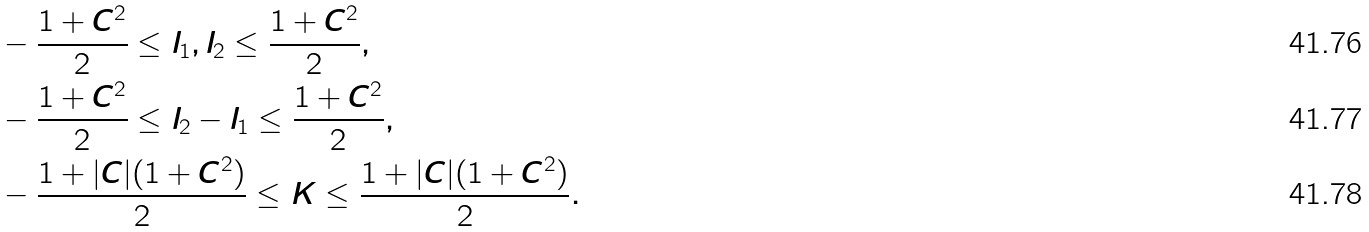Convert formula to latex. <formula><loc_0><loc_0><loc_500><loc_500>& - \frac { 1 + C ^ { 2 } } { 2 } \leq l _ { 1 } , l _ { 2 } \leq \frac { 1 + C ^ { 2 } } { 2 } , \\ & - \frac { 1 + C ^ { 2 } } { 2 } \leq l _ { 2 } - l _ { 1 } \leq \frac { 1 + C ^ { 2 } } { 2 } , \\ & - \frac { 1 + | C | ( 1 + C ^ { 2 } ) } { 2 } \leq K \leq \frac { 1 + | C | ( 1 + C ^ { 2 } ) } { 2 } .</formula> 